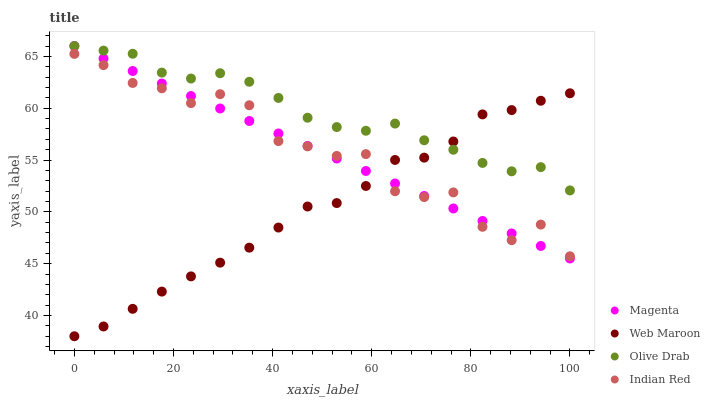Does Web Maroon have the minimum area under the curve?
Answer yes or no. Yes. Does Olive Drab have the maximum area under the curve?
Answer yes or no. Yes. Does Indian Red have the minimum area under the curve?
Answer yes or no. No. Does Indian Red have the maximum area under the curve?
Answer yes or no. No. Is Magenta the smoothest?
Answer yes or no. Yes. Is Indian Red the roughest?
Answer yes or no. Yes. Is Web Maroon the smoothest?
Answer yes or no. No. Is Web Maroon the roughest?
Answer yes or no. No. Does Web Maroon have the lowest value?
Answer yes or no. Yes. Does Indian Red have the lowest value?
Answer yes or no. No. Does Olive Drab have the highest value?
Answer yes or no. Yes. Does Indian Red have the highest value?
Answer yes or no. No. Is Indian Red less than Olive Drab?
Answer yes or no. Yes. Is Olive Drab greater than Indian Red?
Answer yes or no. Yes. Does Olive Drab intersect Magenta?
Answer yes or no. Yes. Is Olive Drab less than Magenta?
Answer yes or no. No. Is Olive Drab greater than Magenta?
Answer yes or no. No. Does Indian Red intersect Olive Drab?
Answer yes or no. No. 